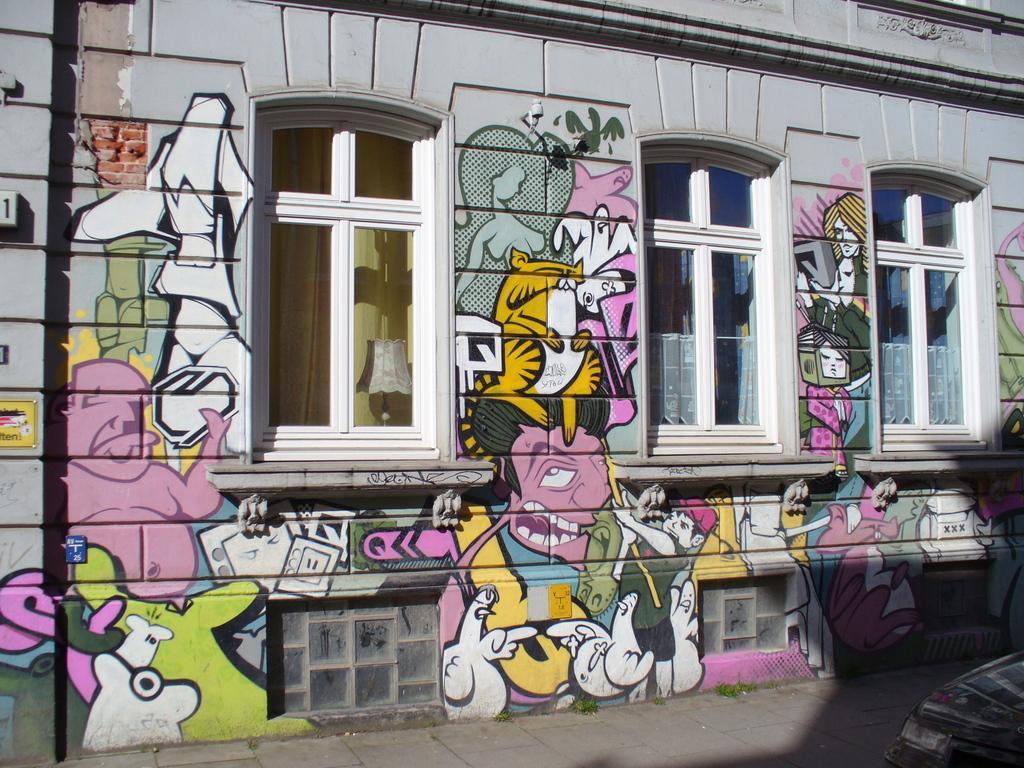Could you give a brief overview of what you see in this image? In this image there is a wall of a building having few windows. Left side there is a lamp behind the window. Few images are painted on the wall. Right bottom there is an object on the pavement. 